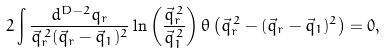<formula> <loc_0><loc_0><loc_500><loc_500>2 \int \frac { d ^ { D - 2 } q _ { r } } { \vec { q } _ { r } ^ { \, 2 } ( \vec { q } _ { r } - \vec { q } _ { 1 } ) ^ { 2 } } \ln \left ( \frac { \vec { q } _ { r } ^ { \, 2 } } { \vec { q } _ { 1 } ^ { \, 2 } } \right ) \theta \left ( \vec { q } _ { r } ^ { \, 2 } - ( \vec { q } _ { r } - \vec { q } _ { 1 } ) ^ { 2 } \right ) = 0 ,</formula> 